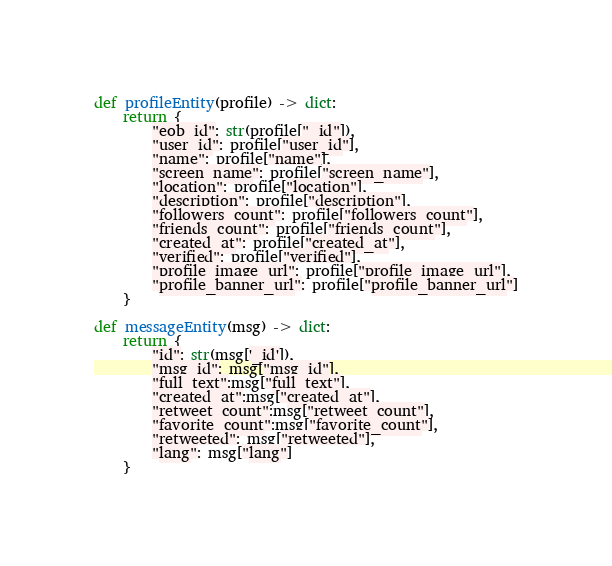<code> <loc_0><loc_0><loc_500><loc_500><_Python_>def profileEntity(profile) -> dict:
    return {
        "eob_id": str(profile["_id"]),
        "user_id": profile["user_id"],
        "name": profile["name"],
        "screen_name": profile["screen_name"],
        "location": profile["location"],
        "description": profile["description"],
        "followers_count": profile["followers_count"],
        "friends_count": profile["friends_count"],
        "created_at": profile["created_at"],
        "verified": profile["verified"],
        "profile_image_url": profile["profile_image_url"],
        "profile_banner_url": profile["profile_banner_url"]
    }

def messageEntity(msg) -> dict:
    return {
        "id": str(msg['_id']),
        "msg_id": msg["msg_id"],
        "full_text":msg["full_text"],
        "created_at":msg["created_at"],
        "retweet_count":msg["retweet_count"],
        "favorite_count":msg["favorite_count"],
        "retweeted": msg["retweeted"],
        "lang": msg["lang"]
    }</code> 